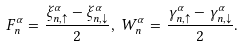Convert formula to latex. <formula><loc_0><loc_0><loc_500><loc_500>F _ { n } ^ { \alpha } = \frac { \xi _ { n , \uparrow } ^ { \alpha } - \xi _ { n , \downarrow } ^ { \alpha } } 2 , \, W _ { n } ^ { \alpha } = \frac { \gamma _ { n , \uparrow } ^ { \alpha } - \gamma _ { n , \downarrow } ^ { \alpha } } 2 .</formula> 